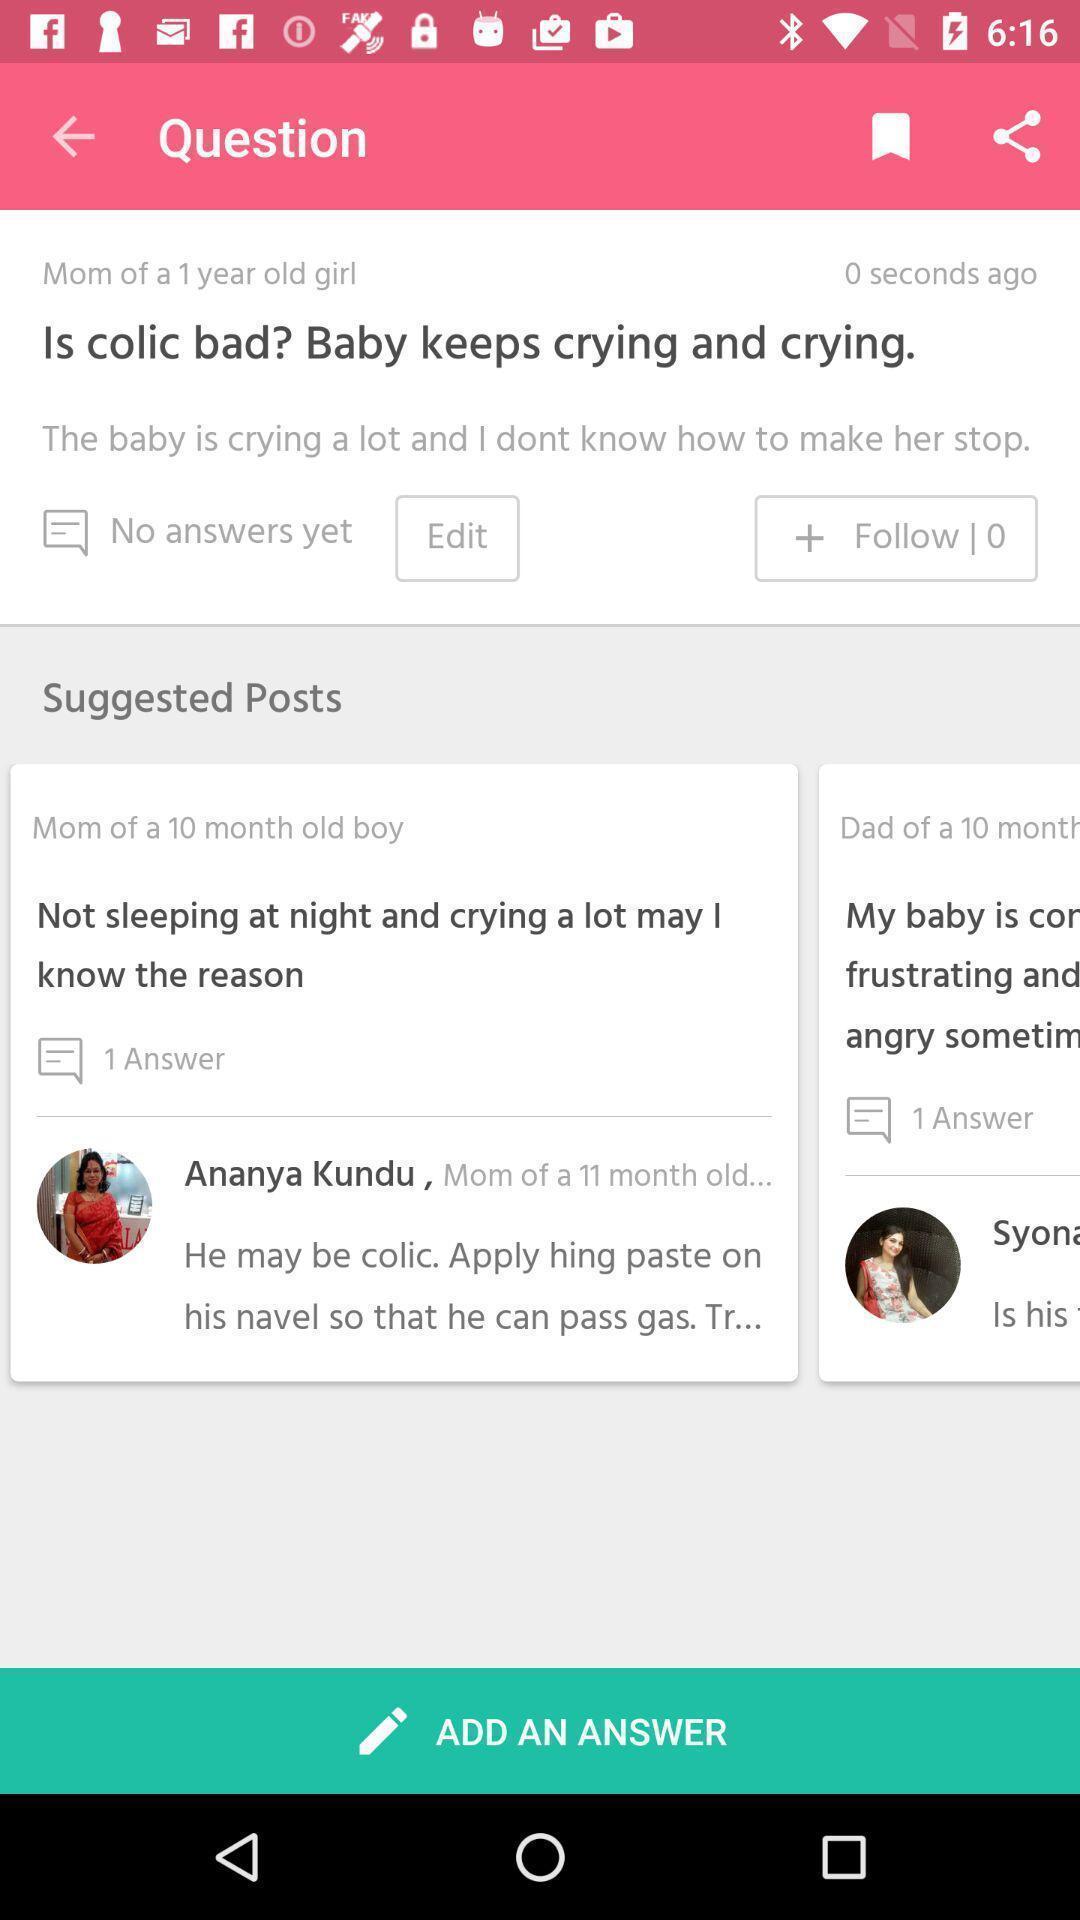Summarize the information in this screenshot. Suggested posts displaying in this page. 